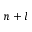Convert formula to latex. <formula><loc_0><loc_0><loc_500><loc_500>n + l</formula> 